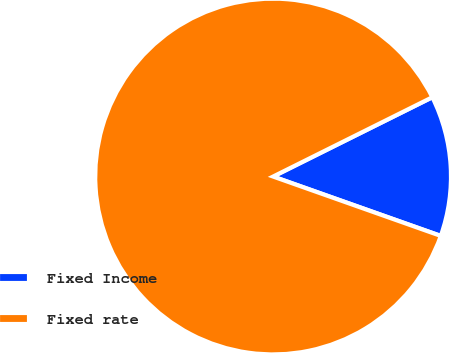Convert chart to OTSL. <chart><loc_0><loc_0><loc_500><loc_500><pie_chart><fcel>Fixed Income<fcel>Fixed rate<nl><fcel>12.77%<fcel>87.23%<nl></chart> 